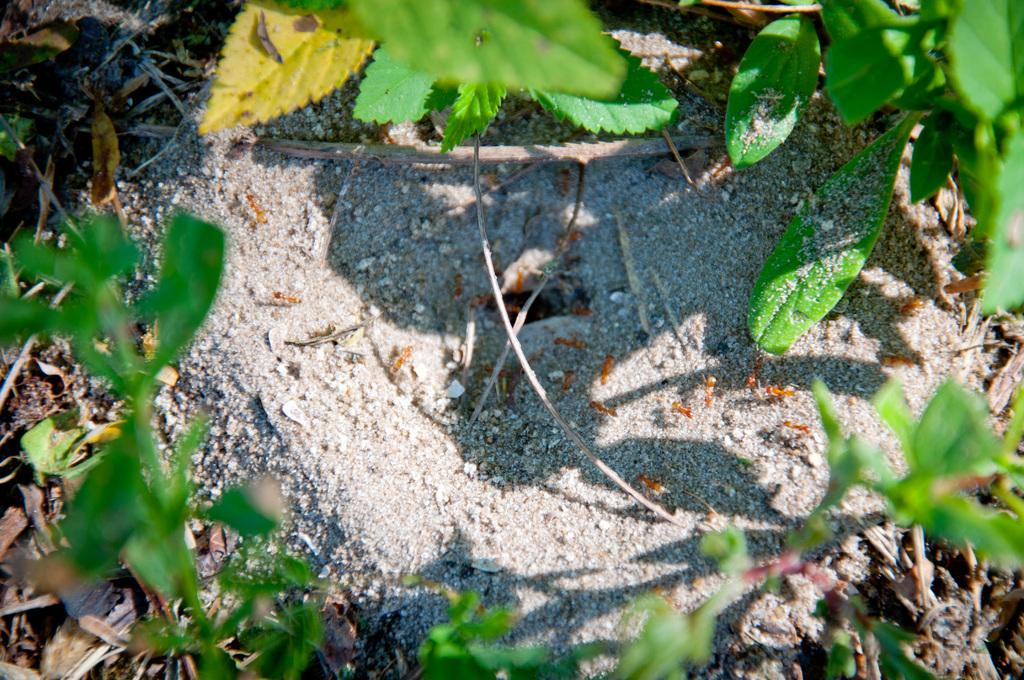What type of living organisms can be seen in the image? Plants and ants are visible in the image. What is the condition of the leaves on the plants in the image? Dried leaves are present in the image. Where are the ants located in the image? The ants are in the middle of the image. What is visible beneath the plants and ants in the image? The ground is visible in the image. What type of dogs can be seen accompanying the ants on their trip in the image? There are no dogs present in the image, and the ants are not depicted as taking a trip. 